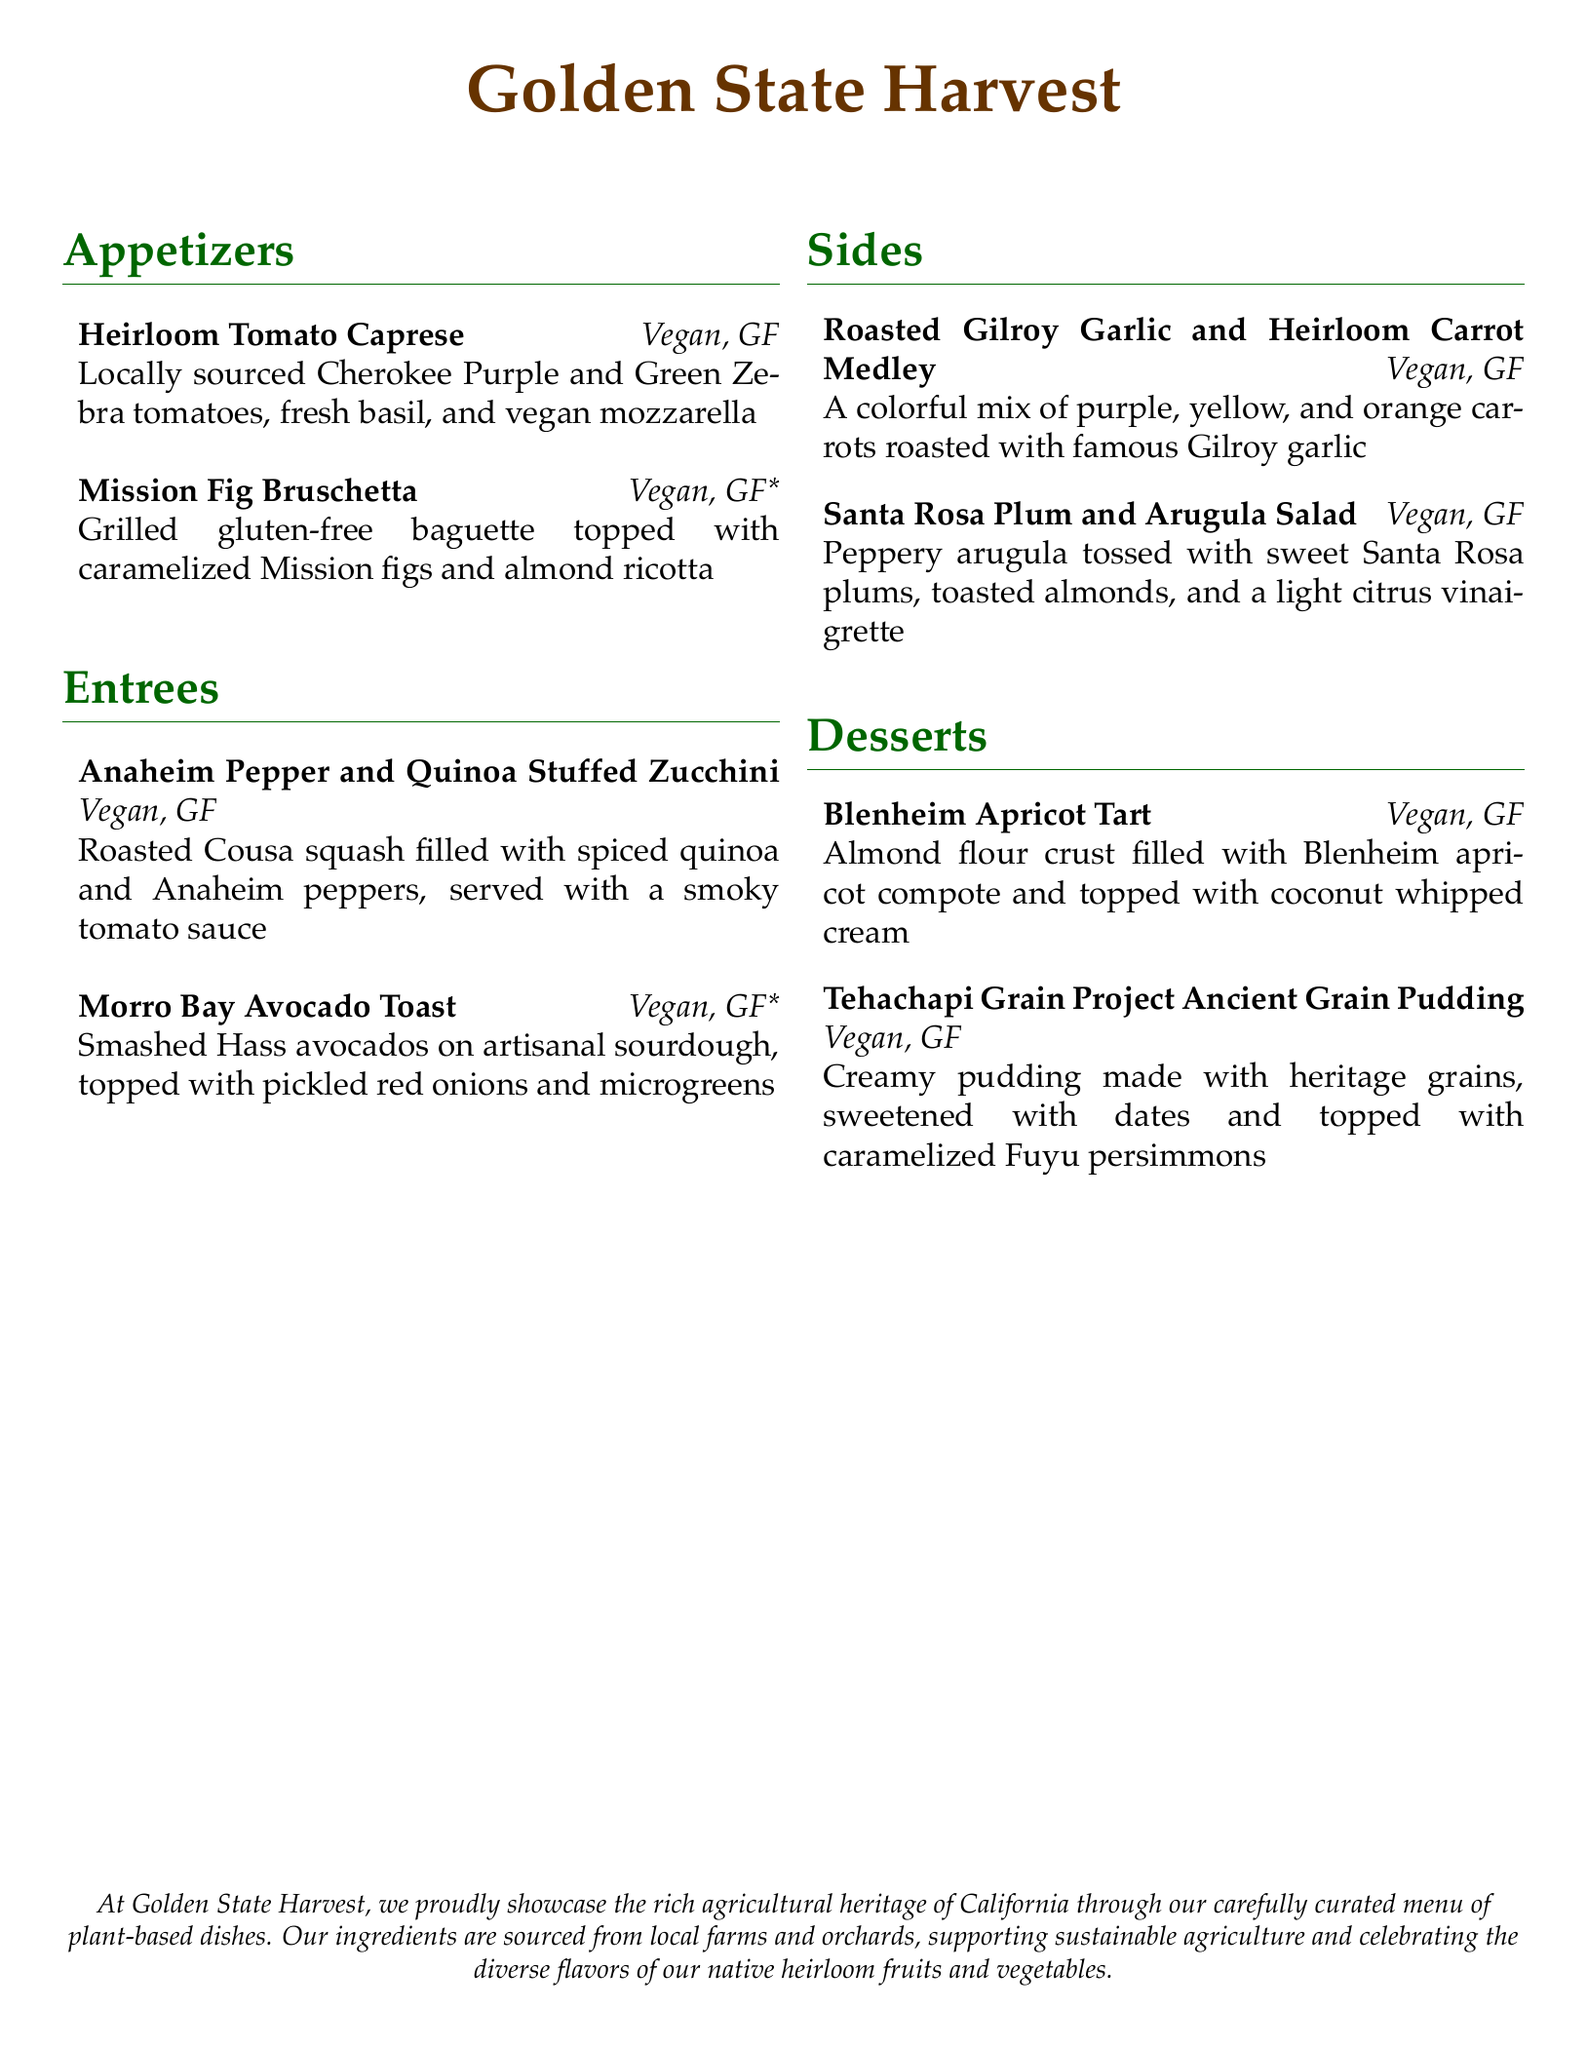What is the name of the restaurant? The name of the restaurant is prominently featured at the top of the menu.
Answer: Golden State Harvest Which section features the Heirloom Tomato Caprese? The Heirloom Tomato Caprese is listed under the Appetizers section.
Answer: Appetizers How many gluten-free options are there in the Entrées section? Both entrées listed in the Entrées section are gluten-free.
Answer: 2 What is the key ingredient in the dessert titled "Blenheim Apricot Tart"? The main ingredient mentioned in the dessert is the type of fruit used in the tart.
Answer: Blenheim apricot What type of lettuce is included in the Santa Rosa Plum and Arugula Salad? The salad contains peppery arugula as specified on the menu.
Answer: Arugula Which dessert features heritage grains? The dessert that mentions heritage grains is highlighted in the Desserts section.
Answer: Tehachapi Grain Project Ancient Grain Pudding Is the Mission Fig Bruschetta a vegan option? The menu clearly indicates whether the dish is vegan or not.
Answer: Yes What is the color of the carrots used in the Roasted Garlic and Heirloom Carrot Medley? The medley includes multiple colors of carrots as described in the menu.
Answer: Purple, yellow, and orange 